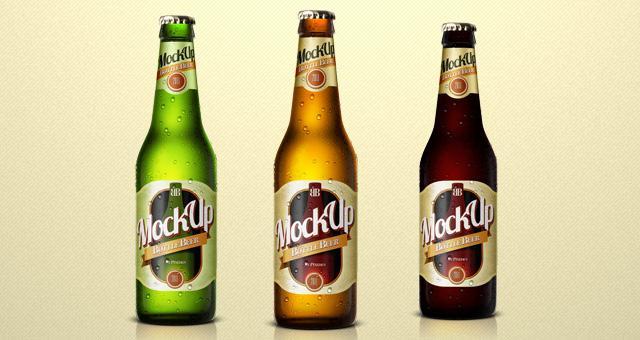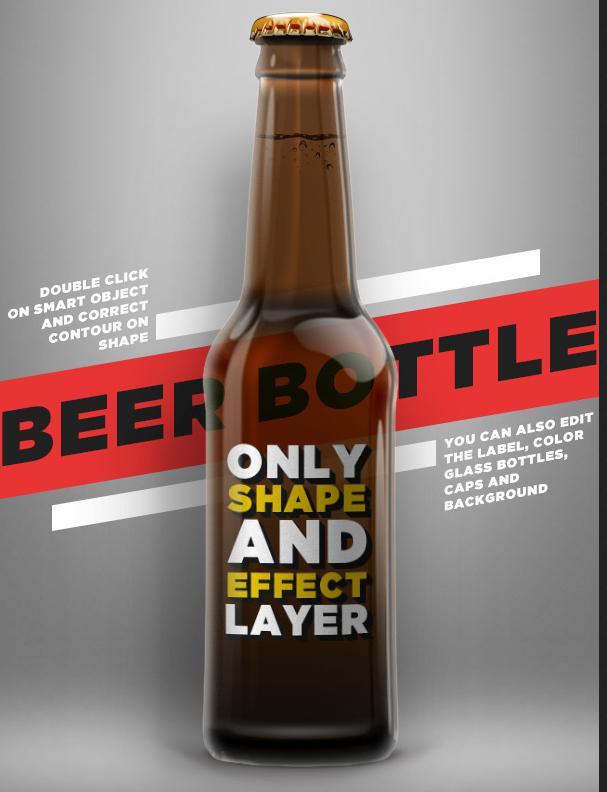The first image is the image on the left, the second image is the image on the right. Analyze the images presented: Is the assertion "There are two glass beer bottles" valid? Answer yes or no. No. 